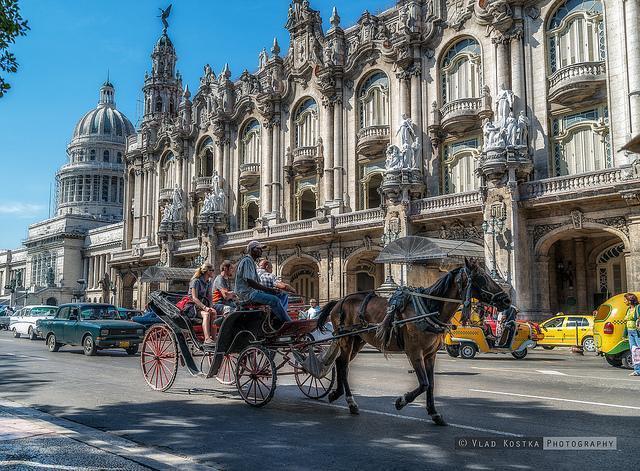How many cars can be seen?
Give a very brief answer. 3. 